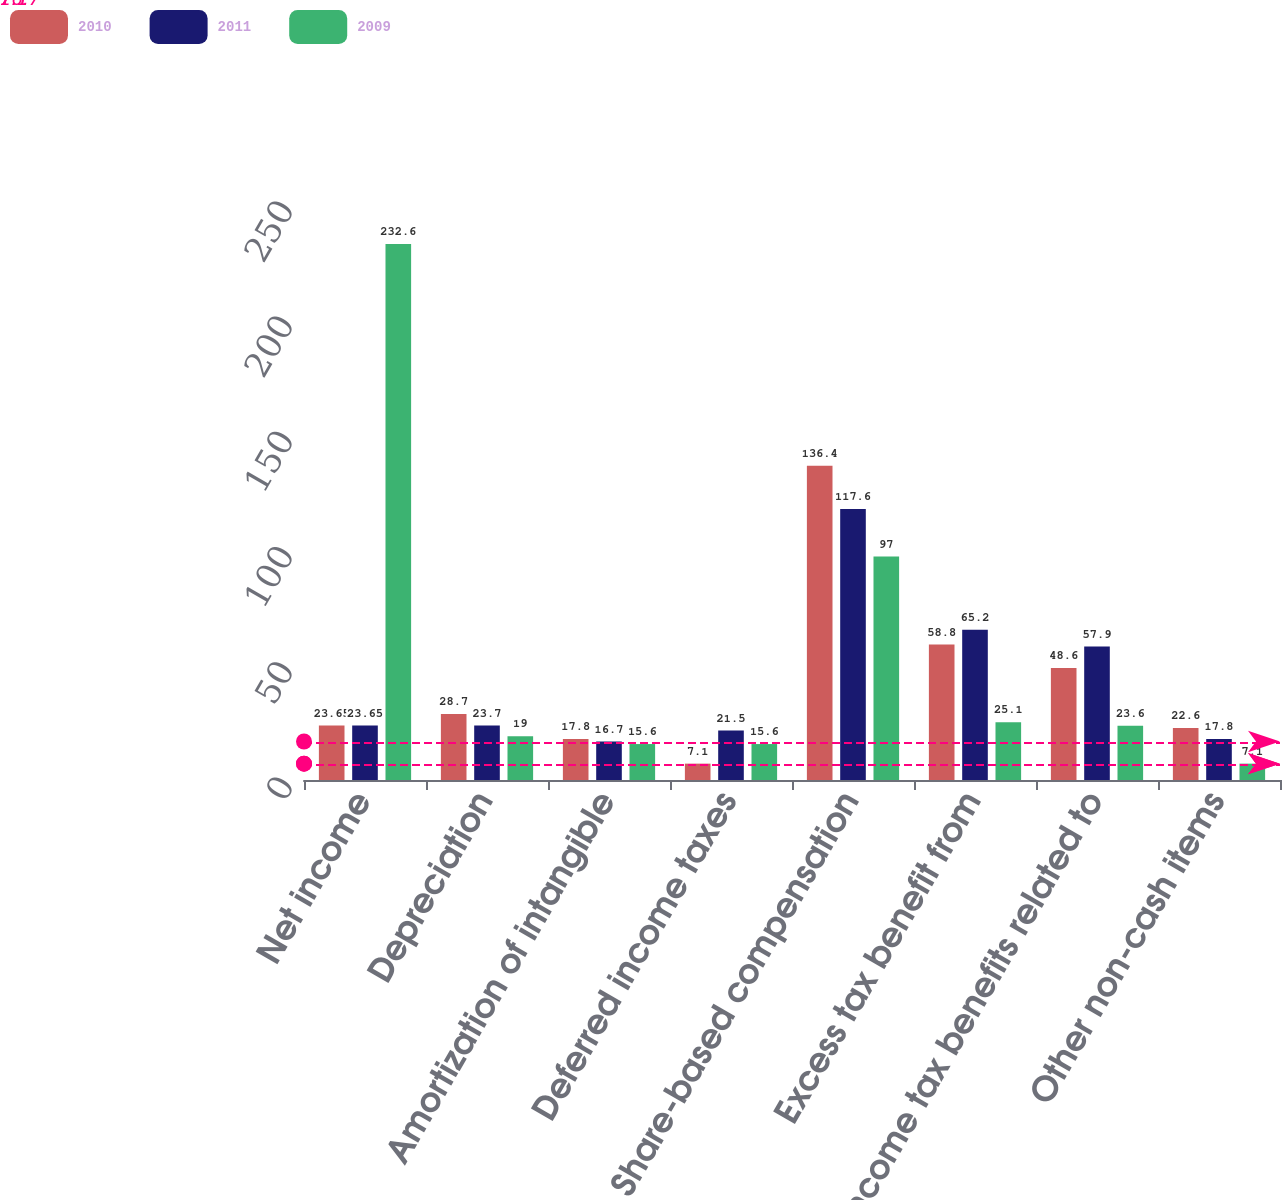Convert chart. <chart><loc_0><loc_0><loc_500><loc_500><stacked_bar_chart><ecel><fcel>Net income<fcel>Depreciation<fcel>Amortization of intangible<fcel>Deferred income taxes<fcel>Share-based compensation<fcel>Excess tax benefit from<fcel>Income tax benefits related to<fcel>Other non-cash items<nl><fcel>2010<fcel>23.65<fcel>28.7<fcel>17.8<fcel>7.1<fcel>136.4<fcel>58.8<fcel>48.6<fcel>22.6<nl><fcel>2011<fcel>23.65<fcel>23.7<fcel>16.7<fcel>21.5<fcel>117.6<fcel>65.2<fcel>57.9<fcel>17.8<nl><fcel>2009<fcel>232.6<fcel>19<fcel>15.6<fcel>15.6<fcel>97<fcel>25.1<fcel>23.6<fcel>7.1<nl></chart> 